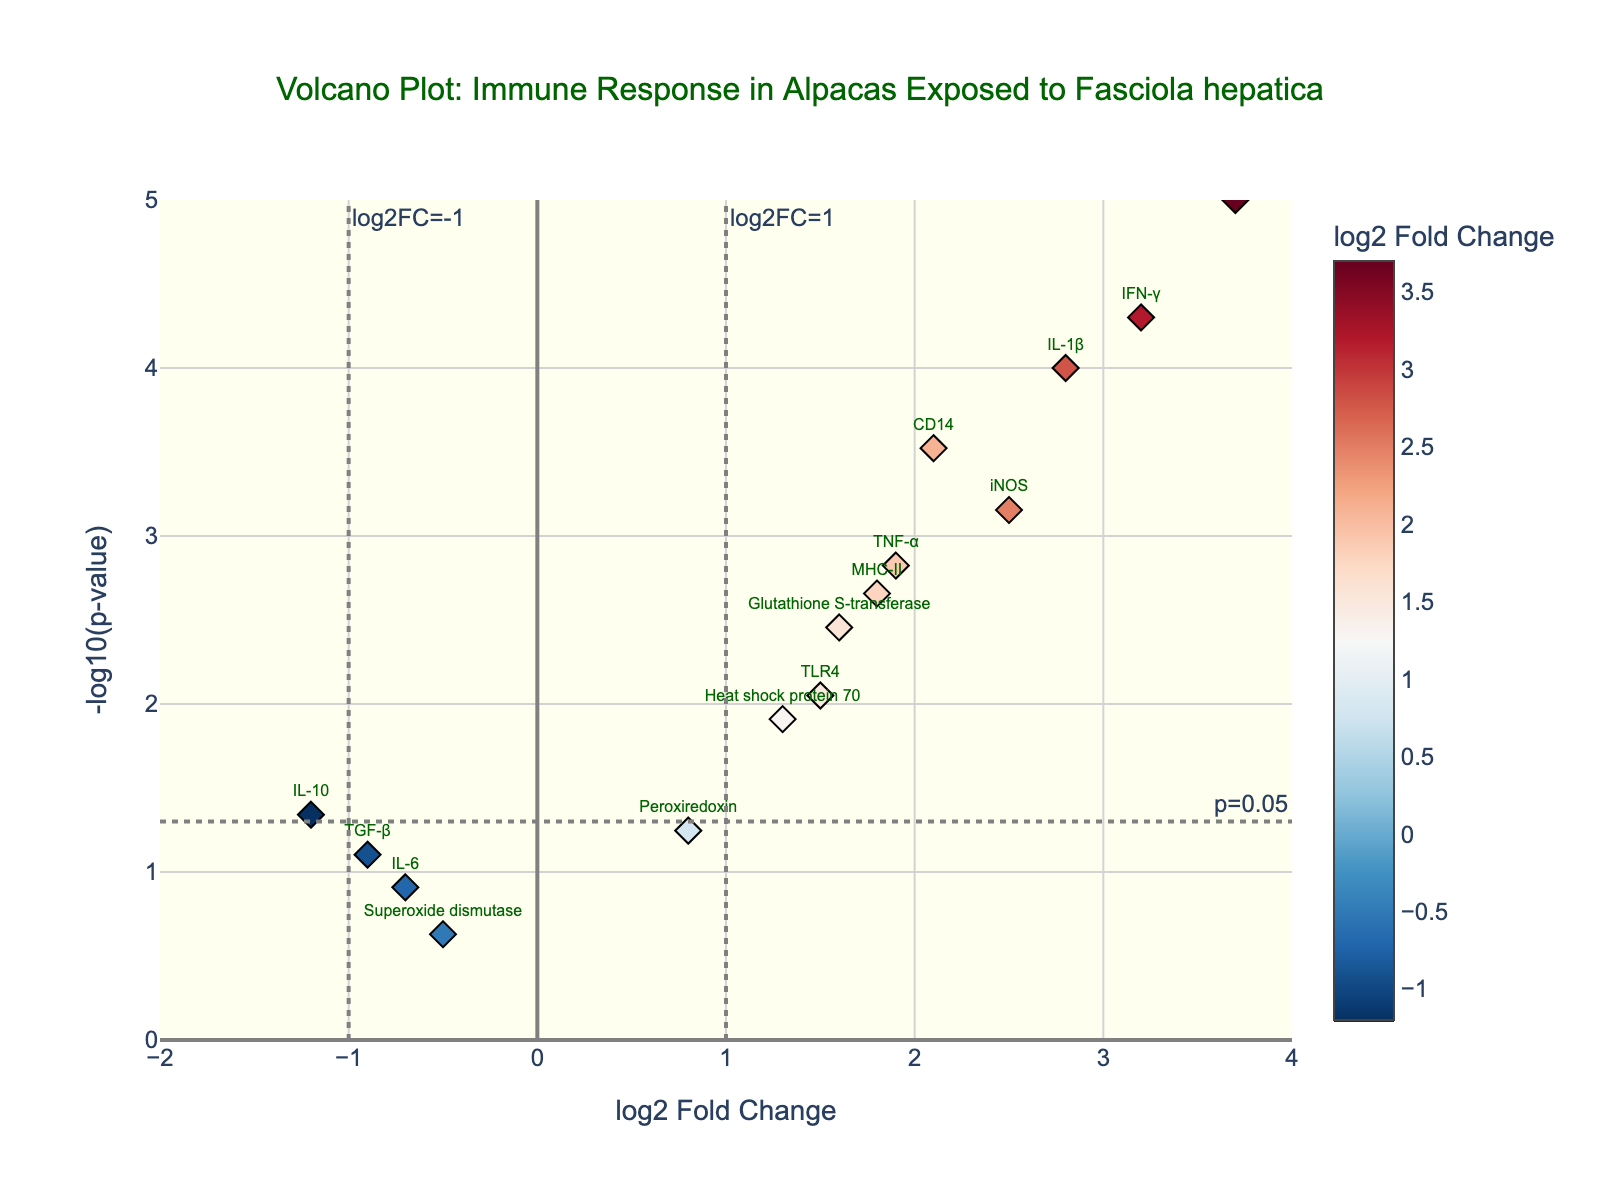What is the title of the plot? The title is located at the top of the volcano plot.
Answer: "Volcano Plot: Immune Response in Alpacas Exposed to Fasciola hepatica" What do the x-axis and y-axis represent? The x-axis represents the log2 fold change, and the y-axis represents the -log10(p-value), as indicated by the axis titles.
Answer: log2 fold change and -log10(p-value) How many genes have a log2 fold change greater than 2.0? To find the number of genes with a log2 fold change greater than 2.0, look for data points positioned to the right of 2.0 on the x-axis. The highlighted genes are IL-1β, IFN-γ, iNOS, and Cathepsin L.
Answer: 4 Which gene has the highest -log10(p-value)? To determine the gene with the highest -log10(p-value), locate the highest point on the y-axis. The gene with the highest value is Cathepsin L.
Answer: Cathepsin L Does IL-6 have a significant p-value? Check if IL-6 has a -log10(p-value) above the threshold line for p=0.05, which is at -log10(0.05) approximately equal to 1.3. IL-6 has a -log10(p-value) below this line.
Answer: No Which genes are downregulated with a p-value less than 0.05? Downregulated genes have a negative log2 fold change and a p-value less than 0.05, placing them to the left of -1.0 on the x-axis. IL-10 fits these criteria.
Answer: IL-10 What is the log2 fold change of IFN-γ and how significant is it? Identify IFN-γ on the plot and check its log2 fold change (3.2) and -log10(p-value) (which is above the threshold of 1.3 for significance).
Answer: 3.2 and significant Compare the -log10(p-value) of TNF-α and Heat shock protein 70. Which one is more significant? Check the positions of TNF-α and Heat shock protein 70 on the y-axis. TNF-α is higher, indicating a lower p-value and thus higher significance.
Answer: TNF-α is more significant Which gene has the smallest log2 fold change and what is its significance level? Determine the minimum log2 fold change value on the x-axis (Superoxide dismutase at -0.5) and check its y-axis position. Superoxide dismutase has a -log10(p-value) below the threshold, making it not significant.
Answer: Superoxide dismutase, not significant 